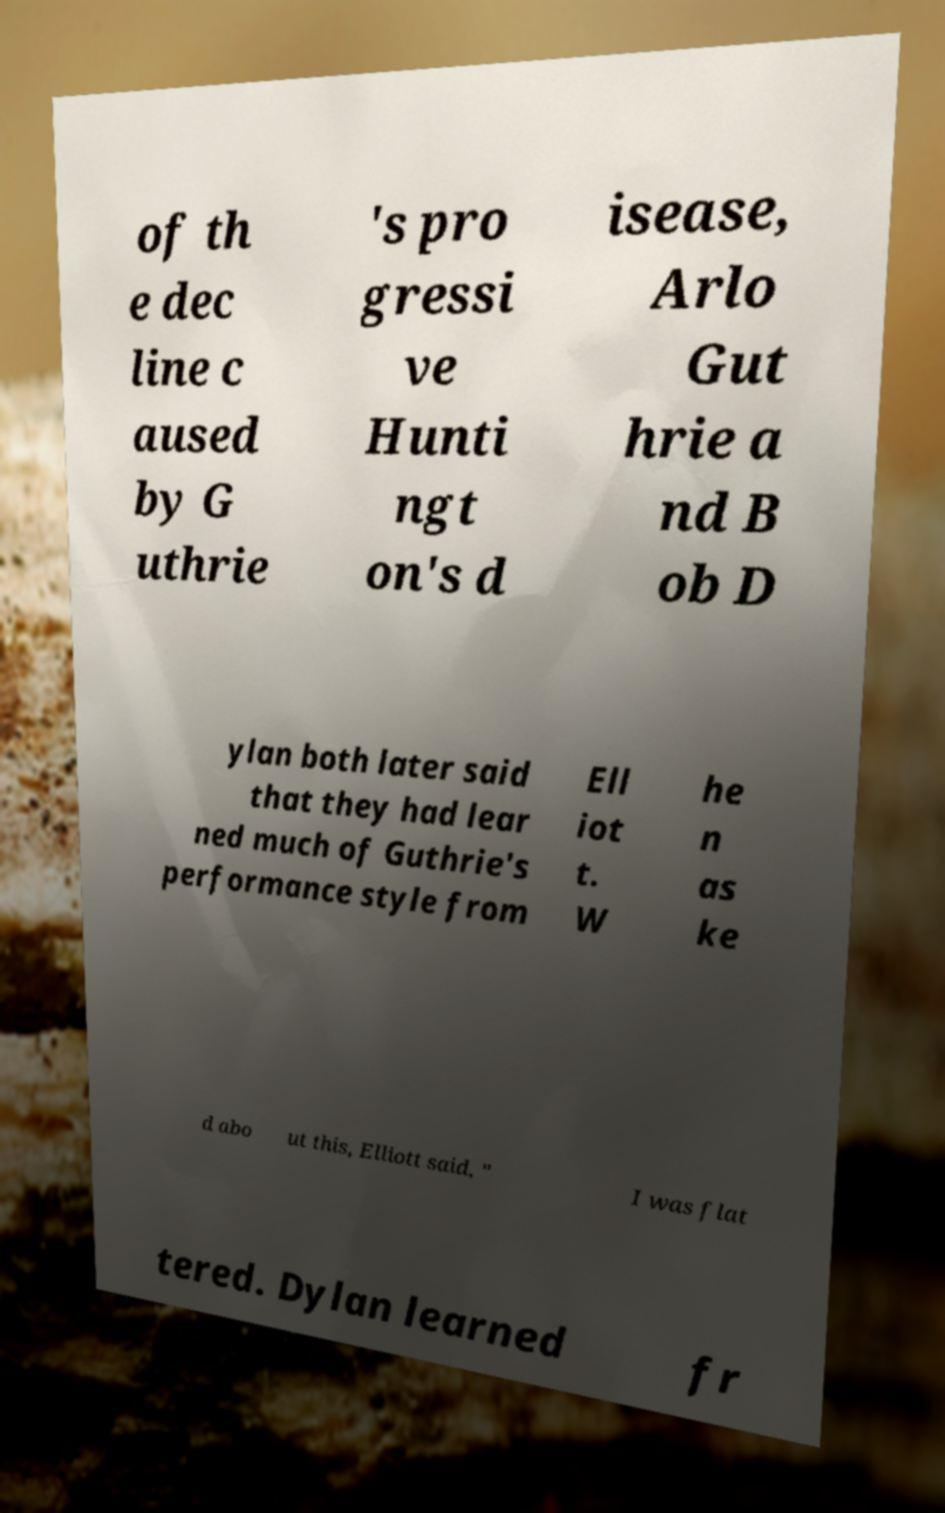Could you extract and type out the text from this image? of th e dec line c aused by G uthrie 's pro gressi ve Hunti ngt on's d isease, Arlo Gut hrie a nd B ob D ylan both later said that they had lear ned much of Guthrie's performance style from Ell iot t. W he n as ke d abo ut this, Elliott said, " I was flat tered. Dylan learned fr 